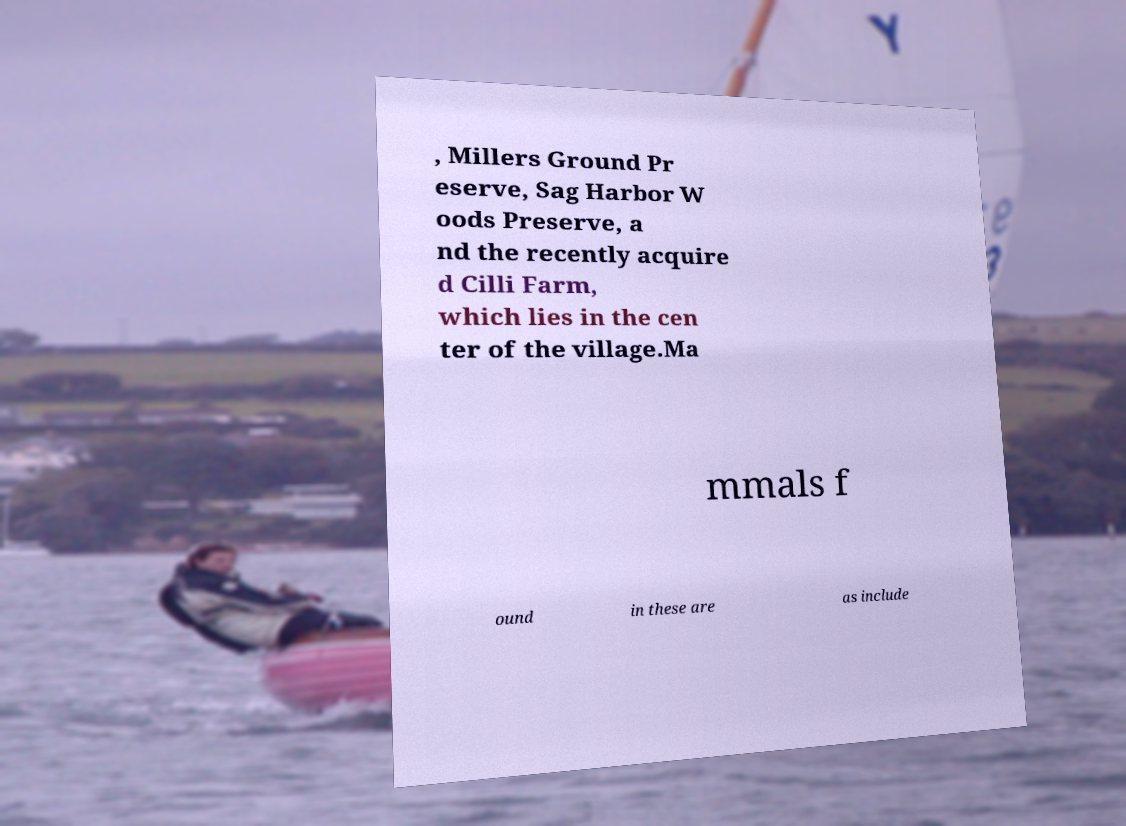Can you read and provide the text displayed in the image?This photo seems to have some interesting text. Can you extract and type it out for me? , Millers Ground Pr eserve, Sag Harbor W oods Preserve, a nd the recently acquire d Cilli Farm, which lies in the cen ter of the village.Ma mmals f ound in these are as include 